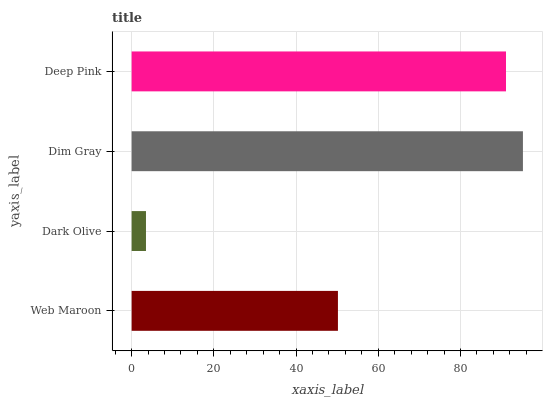Is Dark Olive the minimum?
Answer yes or no. Yes. Is Dim Gray the maximum?
Answer yes or no. Yes. Is Dim Gray the minimum?
Answer yes or no. No. Is Dark Olive the maximum?
Answer yes or no. No. Is Dim Gray greater than Dark Olive?
Answer yes or no. Yes. Is Dark Olive less than Dim Gray?
Answer yes or no. Yes. Is Dark Olive greater than Dim Gray?
Answer yes or no. No. Is Dim Gray less than Dark Olive?
Answer yes or no. No. Is Deep Pink the high median?
Answer yes or no. Yes. Is Web Maroon the low median?
Answer yes or no. Yes. Is Dim Gray the high median?
Answer yes or no. No. Is Dark Olive the low median?
Answer yes or no. No. 